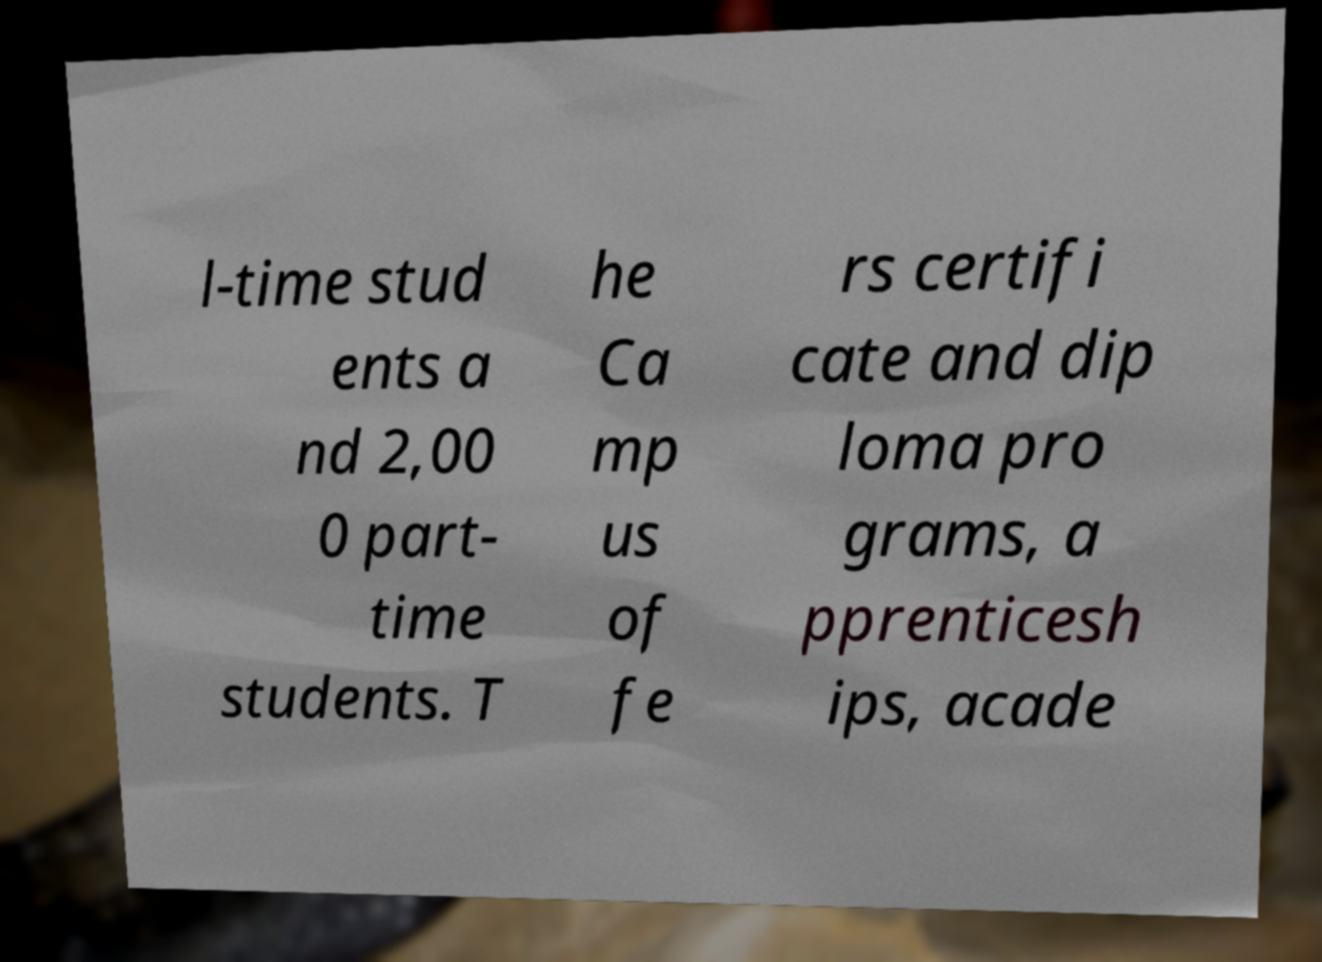Please identify and transcribe the text found in this image. l-time stud ents a nd 2,00 0 part- time students. T he Ca mp us of fe rs certifi cate and dip loma pro grams, a pprenticesh ips, acade 